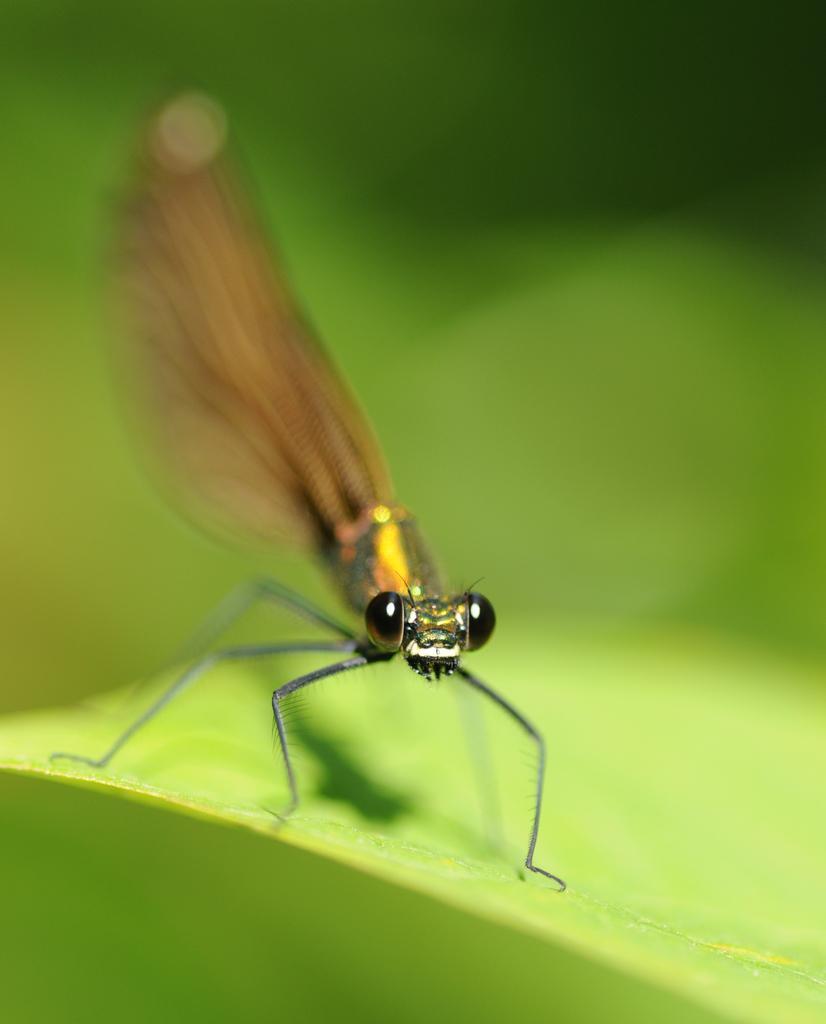In one or two sentences, can you explain what this image depicts? In this picture I can see an insect on the green color thing and I see that it is blurred in the background. 